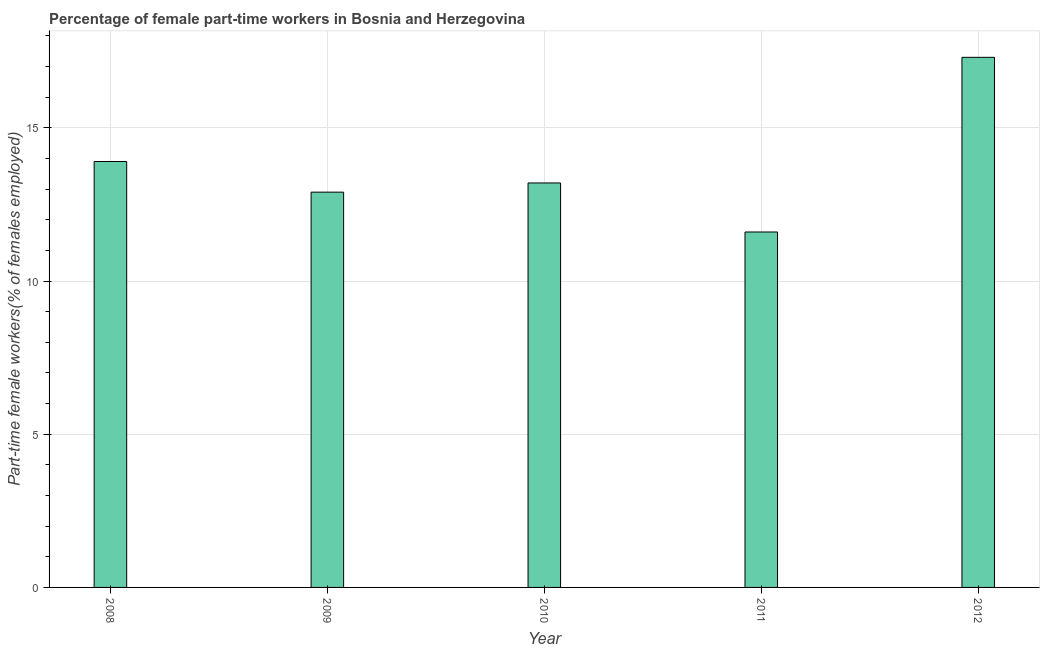Does the graph contain any zero values?
Make the answer very short. No. What is the title of the graph?
Make the answer very short. Percentage of female part-time workers in Bosnia and Herzegovina. What is the label or title of the Y-axis?
Give a very brief answer. Part-time female workers(% of females employed). What is the percentage of part-time female workers in 2010?
Offer a very short reply. 13.2. Across all years, what is the maximum percentage of part-time female workers?
Give a very brief answer. 17.3. Across all years, what is the minimum percentage of part-time female workers?
Ensure brevity in your answer.  11.6. In which year was the percentage of part-time female workers maximum?
Offer a very short reply. 2012. What is the sum of the percentage of part-time female workers?
Ensure brevity in your answer.  68.9. What is the average percentage of part-time female workers per year?
Offer a terse response. 13.78. What is the median percentage of part-time female workers?
Ensure brevity in your answer.  13.2. In how many years, is the percentage of part-time female workers greater than 8 %?
Keep it short and to the point. 5. Do a majority of the years between 2011 and 2012 (inclusive) have percentage of part-time female workers greater than 7 %?
Give a very brief answer. Yes. What is the ratio of the percentage of part-time female workers in 2008 to that in 2012?
Your response must be concise. 0.8. What is the difference between the highest and the second highest percentage of part-time female workers?
Offer a very short reply. 3.4. What is the difference between the highest and the lowest percentage of part-time female workers?
Ensure brevity in your answer.  5.7. In how many years, is the percentage of part-time female workers greater than the average percentage of part-time female workers taken over all years?
Make the answer very short. 2. How many bars are there?
Provide a succinct answer. 5. Are all the bars in the graph horizontal?
Your answer should be compact. No. What is the Part-time female workers(% of females employed) of 2008?
Your response must be concise. 13.9. What is the Part-time female workers(% of females employed) of 2009?
Provide a short and direct response. 12.9. What is the Part-time female workers(% of females employed) in 2010?
Make the answer very short. 13.2. What is the Part-time female workers(% of females employed) of 2011?
Keep it short and to the point. 11.6. What is the Part-time female workers(% of females employed) in 2012?
Your answer should be very brief. 17.3. What is the difference between the Part-time female workers(% of females employed) in 2008 and 2010?
Give a very brief answer. 0.7. What is the difference between the Part-time female workers(% of females employed) in 2008 and 2011?
Your response must be concise. 2.3. What is the difference between the Part-time female workers(% of females employed) in 2008 and 2012?
Offer a very short reply. -3.4. What is the ratio of the Part-time female workers(% of females employed) in 2008 to that in 2009?
Provide a short and direct response. 1.08. What is the ratio of the Part-time female workers(% of females employed) in 2008 to that in 2010?
Make the answer very short. 1.05. What is the ratio of the Part-time female workers(% of females employed) in 2008 to that in 2011?
Your answer should be very brief. 1.2. What is the ratio of the Part-time female workers(% of females employed) in 2008 to that in 2012?
Your answer should be very brief. 0.8. What is the ratio of the Part-time female workers(% of females employed) in 2009 to that in 2010?
Your response must be concise. 0.98. What is the ratio of the Part-time female workers(% of females employed) in 2009 to that in 2011?
Provide a short and direct response. 1.11. What is the ratio of the Part-time female workers(% of females employed) in 2009 to that in 2012?
Keep it short and to the point. 0.75. What is the ratio of the Part-time female workers(% of females employed) in 2010 to that in 2011?
Keep it short and to the point. 1.14. What is the ratio of the Part-time female workers(% of females employed) in 2010 to that in 2012?
Offer a very short reply. 0.76. What is the ratio of the Part-time female workers(% of females employed) in 2011 to that in 2012?
Offer a very short reply. 0.67. 